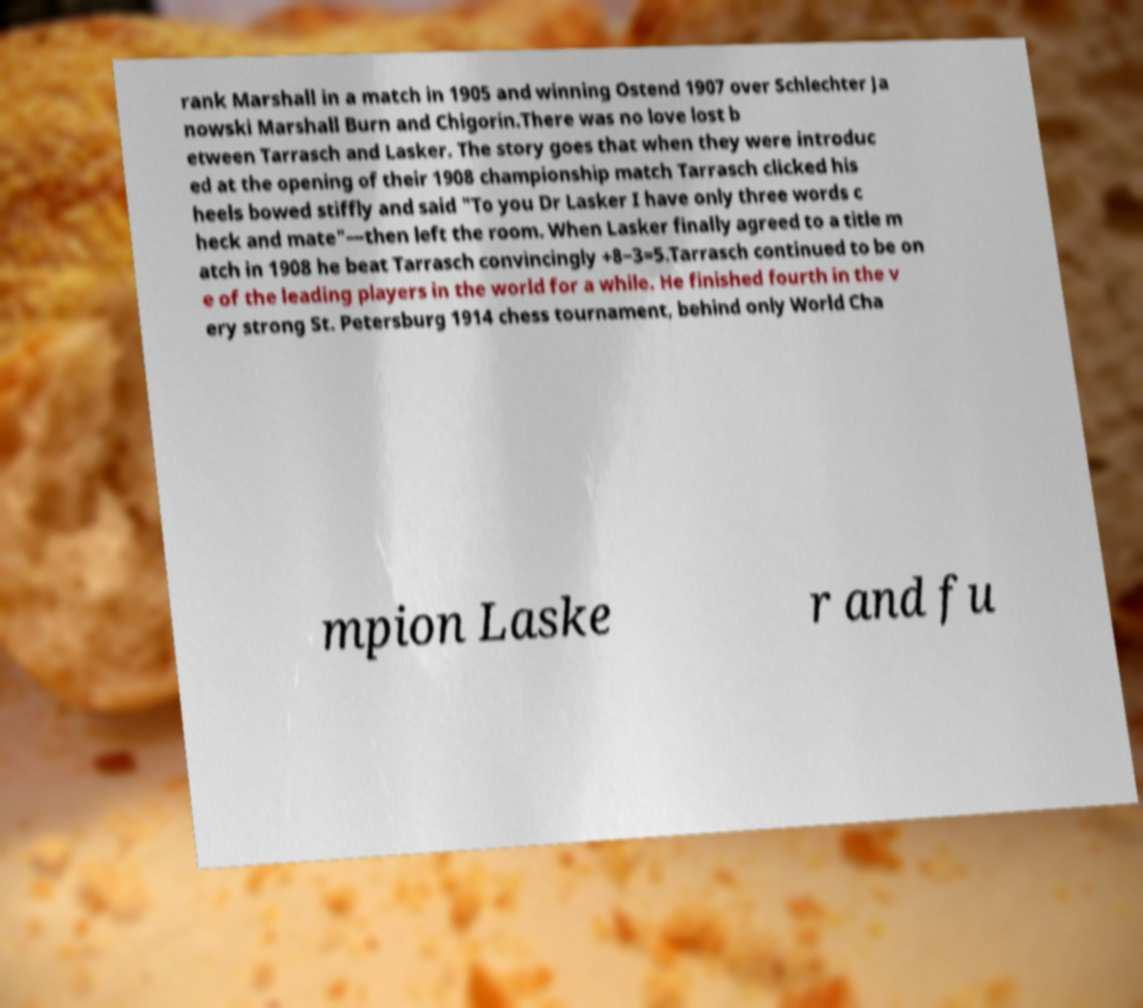Can you read and provide the text displayed in the image?This photo seems to have some interesting text. Can you extract and type it out for me? rank Marshall in a match in 1905 and winning Ostend 1907 over Schlechter Ja nowski Marshall Burn and Chigorin.There was no love lost b etween Tarrasch and Lasker. The story goes that when they were introduc ed at the opening of their 1908 championship match Tarrasch clicked his heels bowed stiffly and said "To you Dr Lasker I have only three words c heck and mate"—then left the room. When Lasker finally agreed to a title m atch in 1908 he beat Tarrasch convincingly +8−3=5.Tarrasch continued to be on e of the leading players in the world for a while. He finished fourth in the v ery strong St. Petersburg 1914 chess tournament, behind only World Cha mpion Laske r and fu 